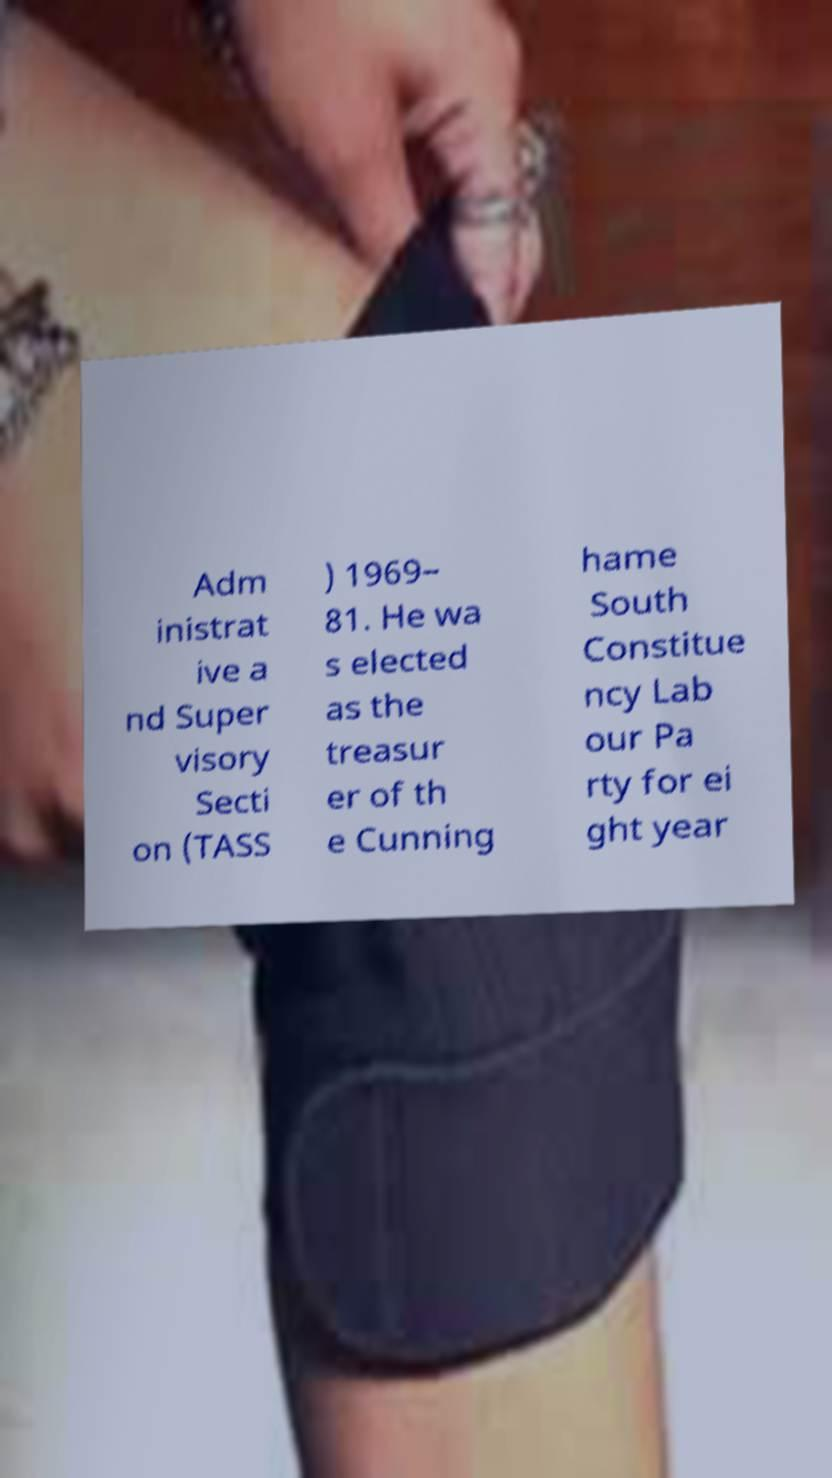Please identify and transcribe the text found in this image. Adm inistrat ive a nd Super visory Secti on (TASS ) 1969– 81. He wa s elected as the treasur er of th e Cunning hame South Constitue ncy Lab our Pa rty for ei ght year 